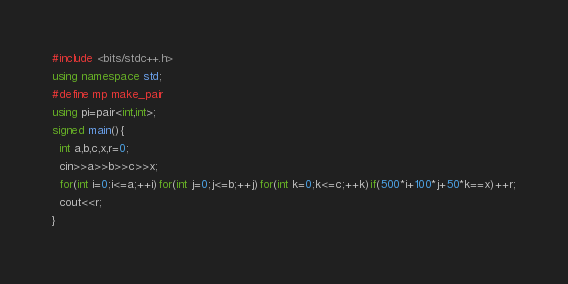Convert code to text. <code><loc_0><loc_0><loc_500><loc_500><_C++_>#include <bits/stdc++.h>
using namespace std;
#define mp make_pair
using pi=pair<int,int>;
signed main(){
  int a,b,c,x,r=0;
  cin>>a>>b>>c>>x;
  for(int i=0;i<=a;++i)for(int j=0;j<=b;++j)for(int k=0;k<=c;++k)if(500*i+100*j+50*k==x)++r;
  cout<<r;
}
</code> 